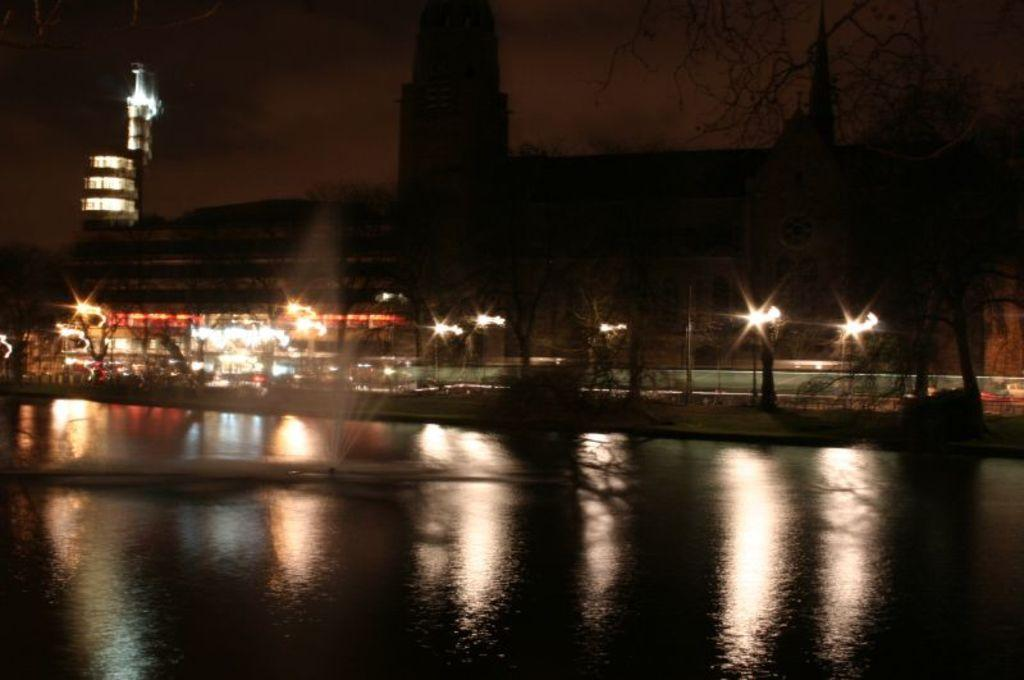What is the main feature in the image? There is a water fountain in the center of the image. What can be seen in the background of the image? There are trees, buildings, and light poles in the background of the image. What is visible at the top of the image? The sky is visible at the top of the image. What type of plants can be seen growing on the water fountain in the image? There are no plants growing on the water fountain in the image. Can you read the note attached to the water fountain in the image? There is no note attached to the water fountain in the image. 